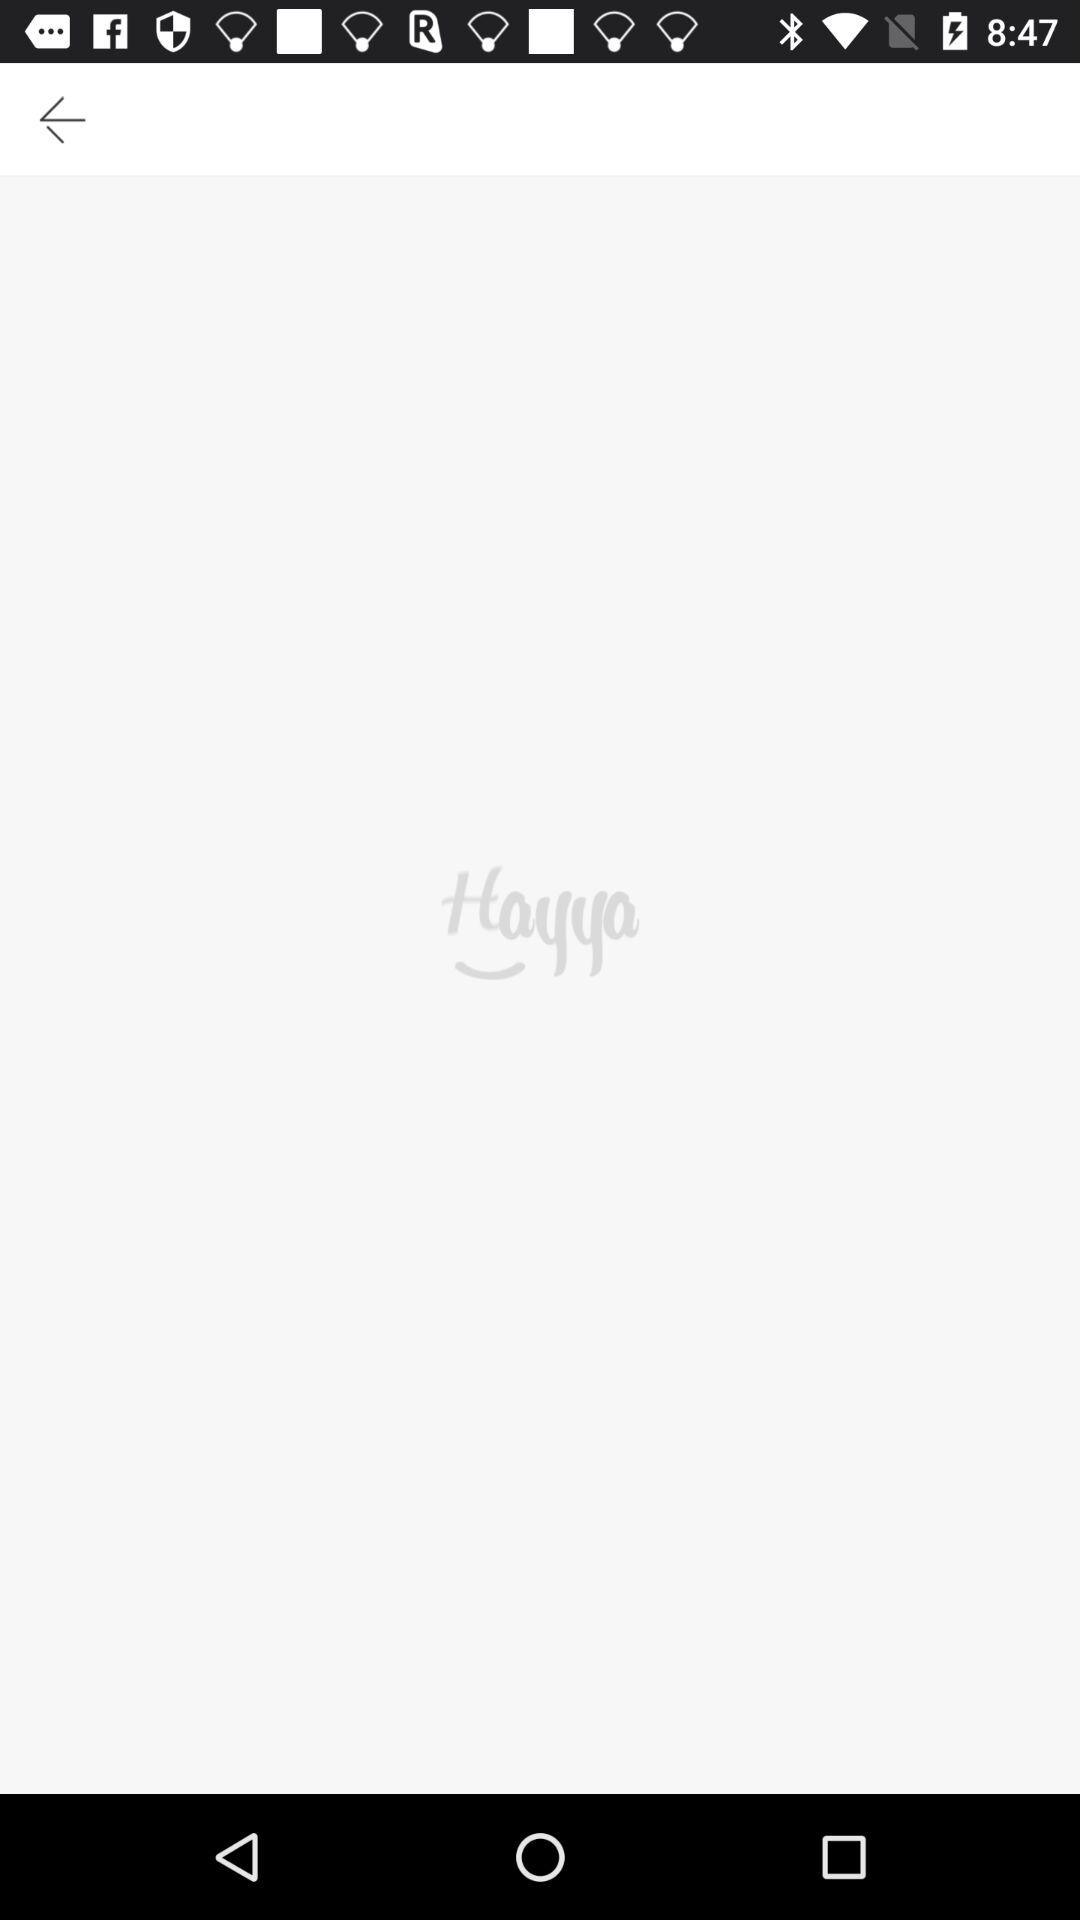What is the application name? The application name is "Hayya". 